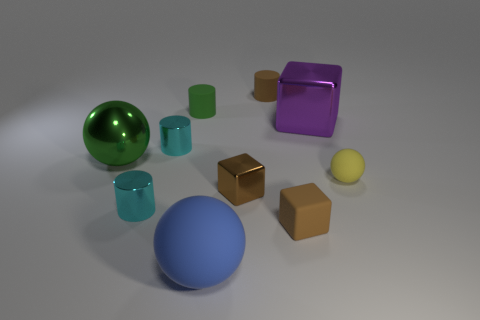Does the tiny matte thing that is in front of the yellow ball have the same color as the tiny metal block?
Your response must be concise. Yes. There is a cyan thing behind the big green thing; what is it made of?
Provide a short and direct response. Metal. Is the number of green cylinders behind the tiny green object the same as the number of large rubber cubes?
Provide a short and direct response. Yes. What number of small rubber spheres are the same color as the small metal block?
Your answer should be very brief. 0. There is another shiny thing that is the same shape as the big purple object; what color is it?
Your answer should be compact. Brown. Does the brown metallic block have the same size as the green metallic ball?
Ensure brevity in your answer.  No. Are there an equal number of tiny brown metallic cubes that are left of the large green sphere and tiny cylinders right of the big blue thing?
Your answer should be very brief. No. Are there any tiny blue metal cylinders?
Your response must be concise. No. There is a green shiny object that is the same shape as the large blue thing; what size is it?
Keep it short and to the point. Large. There is a green thing in front of the big purple metallic cube; how big is it?
Your answer should be very brief. Large. 